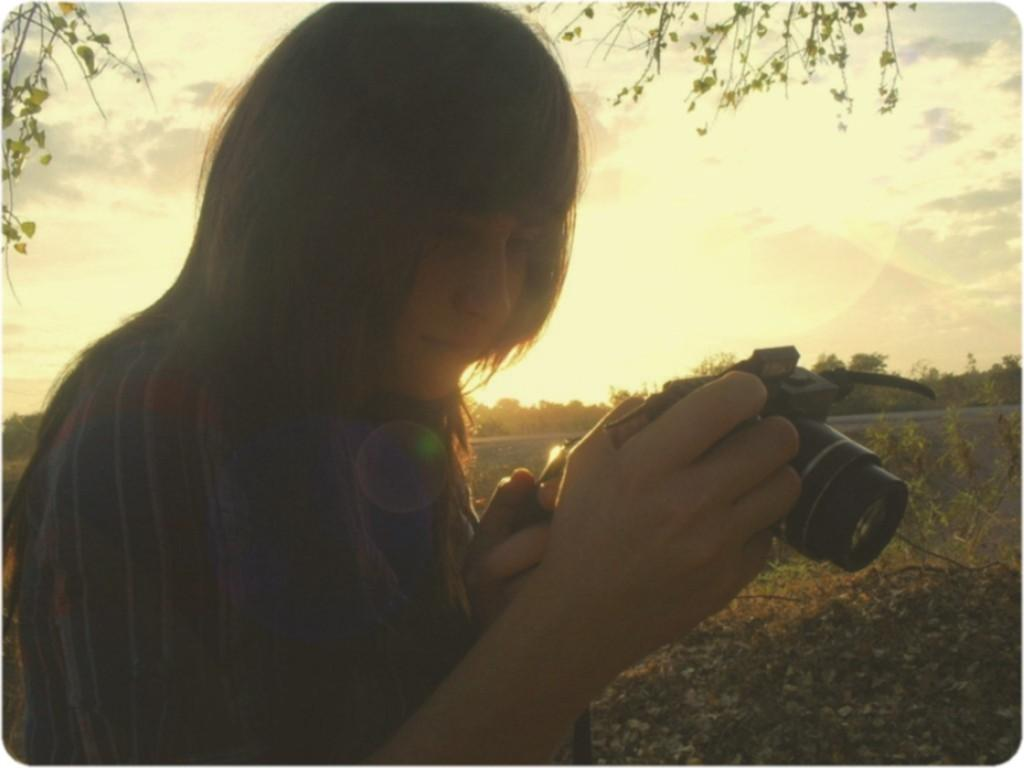Who is the main subject in the image? There is a woman in the image. What is the woman holding in the image? The woman is holding a camera. What can be seen in the background of the image? There are trees on the land in the background of the image. What is visible in the sky in the image? The sky is visible in the image, and clouds are present. How many ladybugs are on the woman's shoulder in the image? There are no ladybugs present in the image. What message is the maid conveying to the woman in the image? There is no maid present in the image, and therefore no message can be conveyed. 